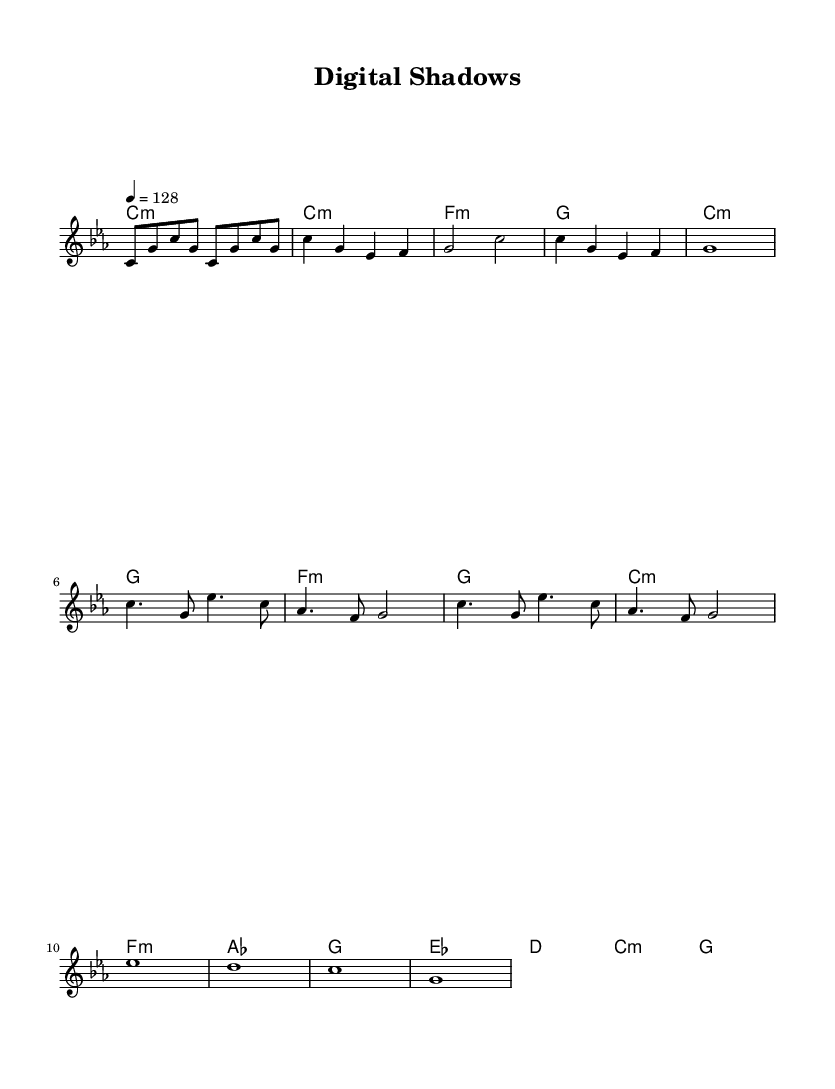What is the key signature of this music? The key signature is C minor, which has three flats (B flat, E flat, A flat). This can be inferred from the indication at the beginning of the score.
Answer: C minor What is the time signature of this music? The time signature is 4/4, as indicated at the beginning of the score. This means there are four beats in each measure, and the quarter note receives one beat.
Answer: 4/4 What is the tempo marking of this music? The tempo marking is 128 beats per minute, as shown in the score near the beginning. This indicates how quickly the piece should be played.
Answer: 128 How many measures are in the chorus section? The chorus section consists of 4 measures, indicated by the repeated structure of the notes and the lyrics associated with that part of the song.
Answer: 4 What musical form does this piece primarily follow? The piece follows a verse-chorus structure, commonly found in pop music, based on the organization of lyrics and sections in the score.
Answer: Verse-Chorus What themes are highlighted in the lyrics of this music? The lyrics emphasize digital threats and cyber warfare, evident from phrases like "cyber warfare," "malware," and "digital shadows," which reflect the overarching subject matter.
Answer: Digital threats What instruments would typically perform a synthesizer pop song like this? This song would typically be performed using synthesizers, drum machines, and electronic elements, which are characteristic of the synth-pop genre.
Answer: Synthesizers 